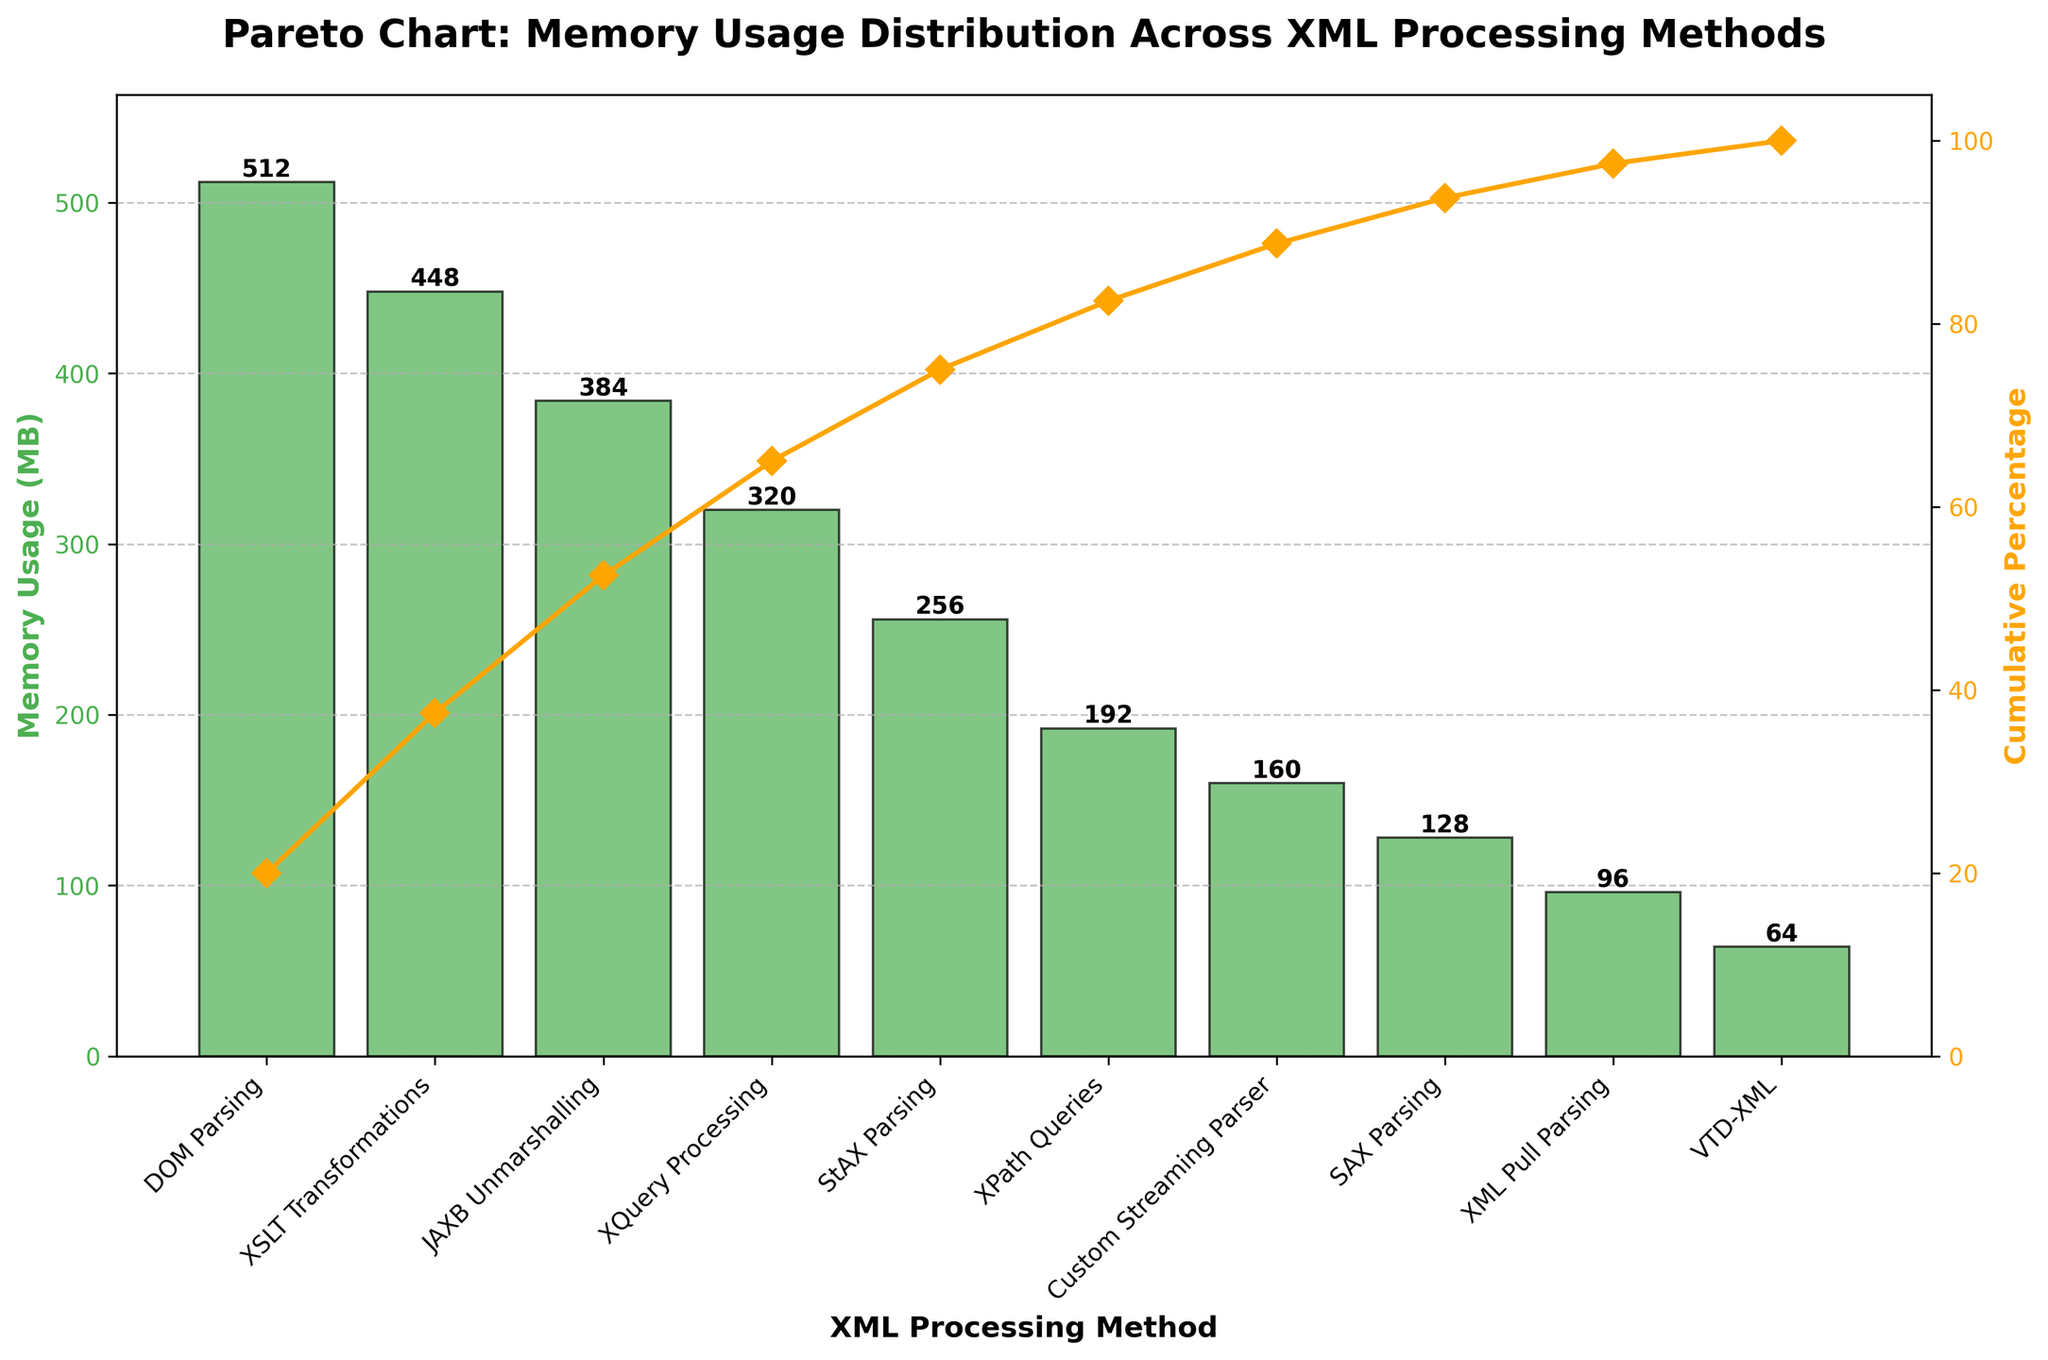What is the title of the figure? The title is placed at the top center of the figure and usually represents the overall subject being depicted.
Answer: Pareto Chart: Memory Usage Distribution Across XML Processing Methods What is the memory usage of the method with the highest value? The height of the tallest bar represents the highest memory usage. The x-axis label underneath it indicates the corresponding method.
Answer: 512 MB (DOM Parsing) Which method has the lowest memory usage? The shortest bar indicates the lowest memory usage, and the x-axis label underneath it specifies the corresponding method.
Answer: VTD-XML What is the cumulative percentage when SAX Parsing is considered? The cumulative percentage line is plotted for each method. Locate SAX Parsing along the x-axis and follow the line plot upwards to find its y-axis value for the cumulative percentage.
Answer: 20% Sum the memory usage of XML Pull Parsing and Custom Streaming Parser. Find the bar heights for XML Pull Parsing and Custom Streaming Parser on the y-axis to get their values, 96 MB and 160 MB, respectively, then sum them up.
Answer: 256 MB What percentage of the total memory usage is covered by DOM Parsing, SAX Parsing, and StAX Parsing combined? Add the memory usage of DOM Parsing (512 MB), SAX Parsing (128 MB), and StAX Parsing (256 MB) to get a combined usage of 896 MB. Then, calculate the percentage of the total (2256 MB) they constitute. (896 / 2256) * 100.
Answer: ~39.73% Compare the memory usage of JAXB Unmarshalling and XSLT Transformations. Which one uses more memory and by how much? Locate the bars for JAXB Unmarshalling and XSLT Transformations, then find their heights on the y-axis to get their values, 384 MB and 448 MB, respectively. Subtract the memory usage of JAXB Unmarshalling from XSLT Transformations.
Answer: XSLT Transformations by 64 MB What cumulative percentage is achieved after including XSLT Transformations? Refer to the cumulative percentage line plotted over the bars. Find the point corresponding to XSLT Transformations and read its y-axis value.
Answer: ~78.7% If you needed to reduce memory usage by 50%, which methods (in descending order) would you eliminate? Calculate 50% of the total memory usage, which is 1128 MB. Exclude methods starting from the highest until their combined memory usage exceeds 1128 MB.
Answer: DOM Parsing, XSLT Transformations, JAXB Unmarshalling, XQuery Processing Which method contributes to reaching approximately the 80% cumulative percentage threshold? Follow the cumulative percentage line close to the 80% mark on the y-axis to find the corresponding method on the x-axis.
Answer: XPath Queries 